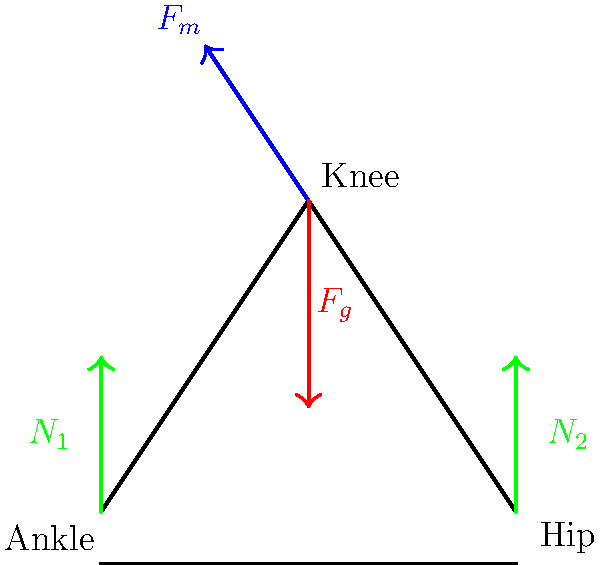In the context of exercise routines and their impact on joint health, consider the free body diagram of a person performing a squat exercise. The diagram shows the forces acting on the knee joint. If the magnitude of the muscle force ($F_m$) is 1000 N and the gravitational force ($F_g$) is 800 N, what is the magnitude of the total force experienced by the knee joint? How might this information be used to inform policies regarding workplace ergonomics and consumer health products? To solve this problem and understand its policy implications, let's follow these steps:

1) Identify the forces acting on the knee joint:
   - Muscle force ($F_m$): 1000 N, acting upwards and to the left
   - Gravitational force ($F_g$): 800 N, acting downwards

2) Decompose the forces into vertical and horizontal components:
   - $F_m$ vertical = 1000 * sin(60°) ≈ 866 N
   - $F_m$ horizontal = 1000 * cos(60°) ≈ 500 N
   - $F_g$ vertical = 800 N
   - $F_g$ horizontal = 0 N

3) Calculate the net force in each direction:
   - Vertical: 866 N - 800 N = 66 N (upwards)
   - Horizontal: 500 N (to the left)

4) Calculate the magnitude of the total force using the Pythagorean theorem:
   $F_{total} = \sqrt{66^2 + 500^2} ≈ 504 N$

5) Policy implications:
   - This information can be used to set guidelines for safe exercise practices, especially for workplace wellness programs.
   - It can inform the design of ergonomic equipment and consumer health products to minimize joint stress.
   - Policymakers can use this data to balance the interests of fitness equipment manufacturers with consumer safety concerns.
   - It can contribute to occupational health policies, especially for jobs requiring repetitive movements or heavy lifting.
   - This knowledge can guide the development of health education programs, emphasizing the importance of proper form during exercise to prevent joint injuries.
Answer: 504 N 